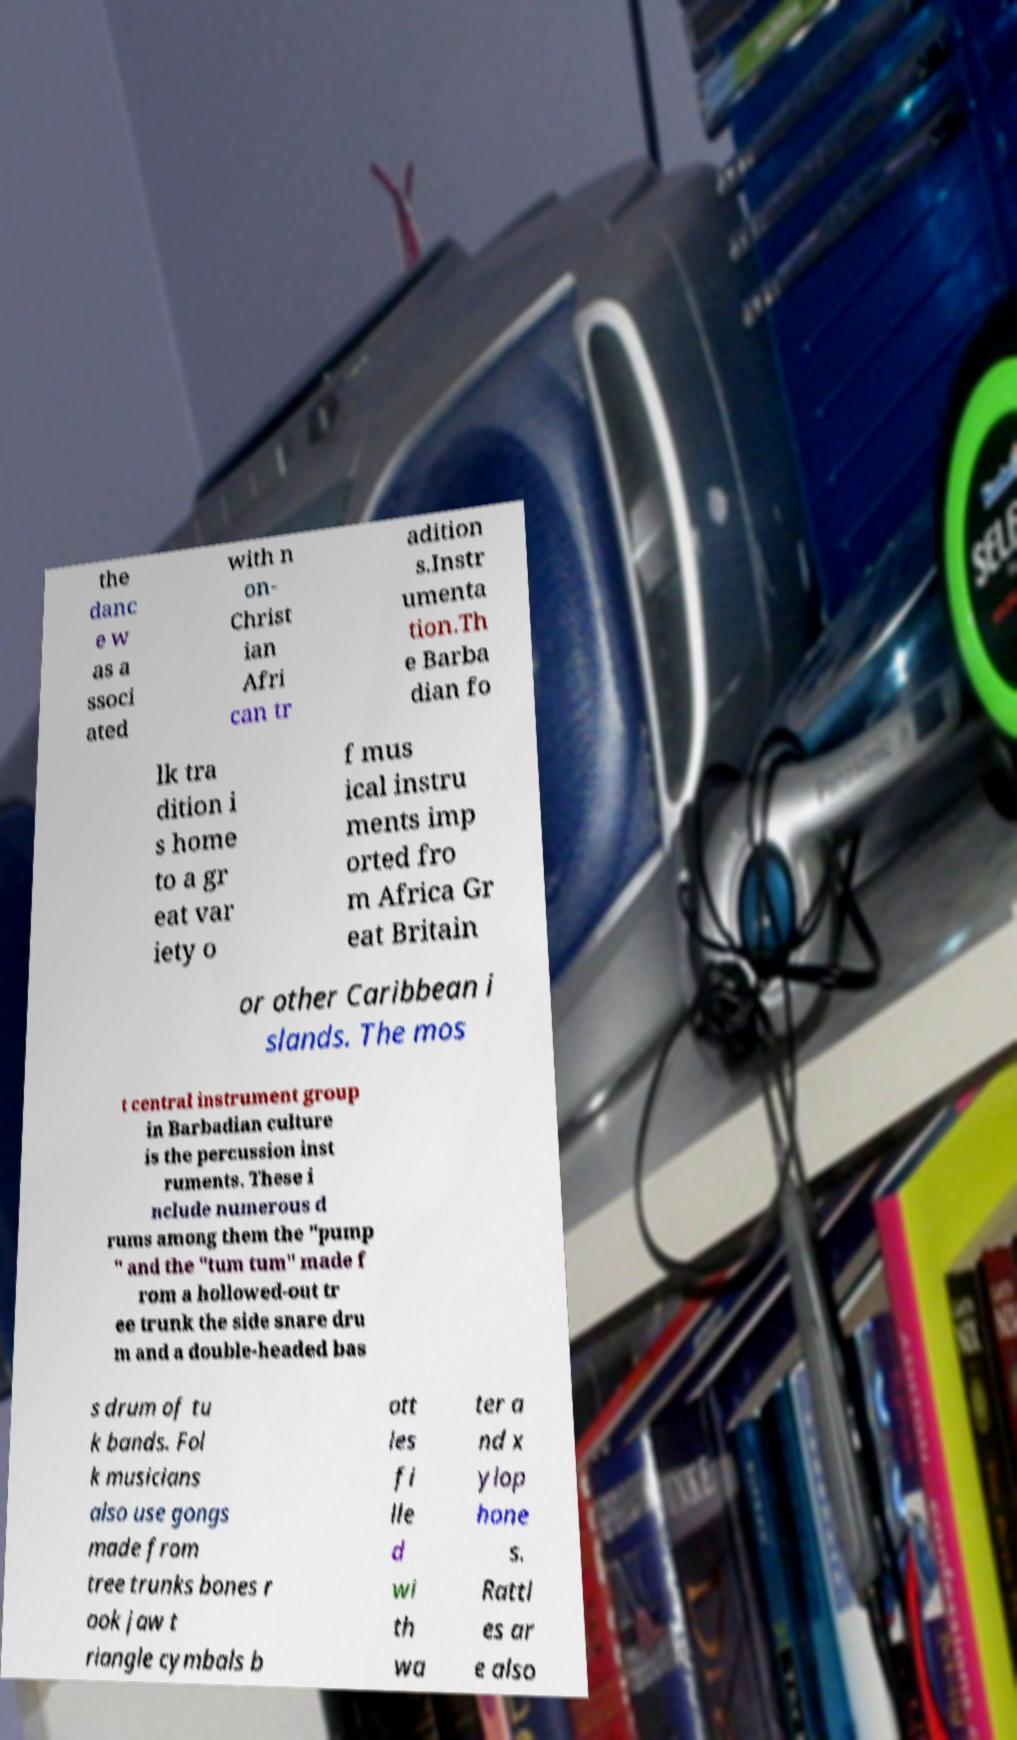I need the written content from this picture converted into text. Can you do that? the danc e w as a ssoci ated with n on- Christ ian Afri can tr adition s.Instr umenta tion.Th e Barba dian fo lk tra dition i s home to a gr eat var iety o f mus ical instru ments imp orted fro m Africa Gr eat Britain or other Caribbean i slands. The mos t central instrument group in Barbadian culture is the percussion inst ruments. These i nclude numerous d rums among them the "pump " and the "tum tum" made f rom a hollowed-out tr ee trunk the side snare dru m and a double-headed bas s drum of tu k bands. Fol k musicians also use gongs made from tree trunks bones r ook jaw t riangle cymbals b ott les fi lle d wi th wa ter a nd x ylop hone s. Rattl es ar e also 